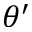<formula> <loc_0><loc_0><loc_500><loc_500>\theta ^ { \prime }</formula> 